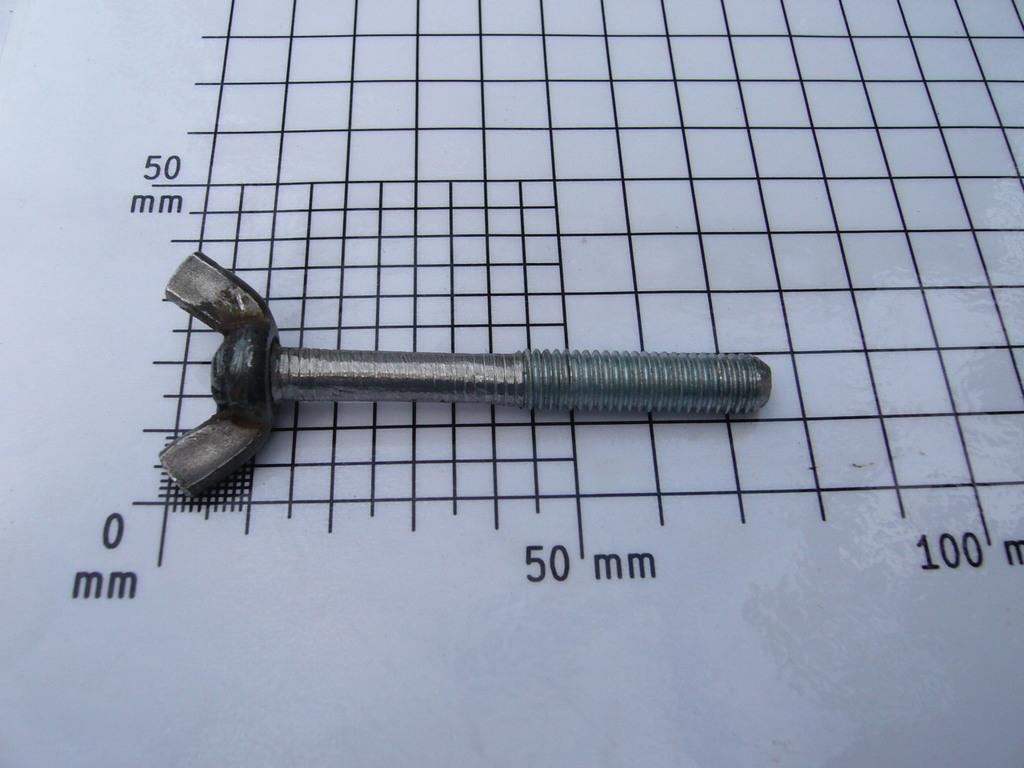<image>
Present a compact description of the photo's key features. a graph that has 50 mm at the bottom of it 